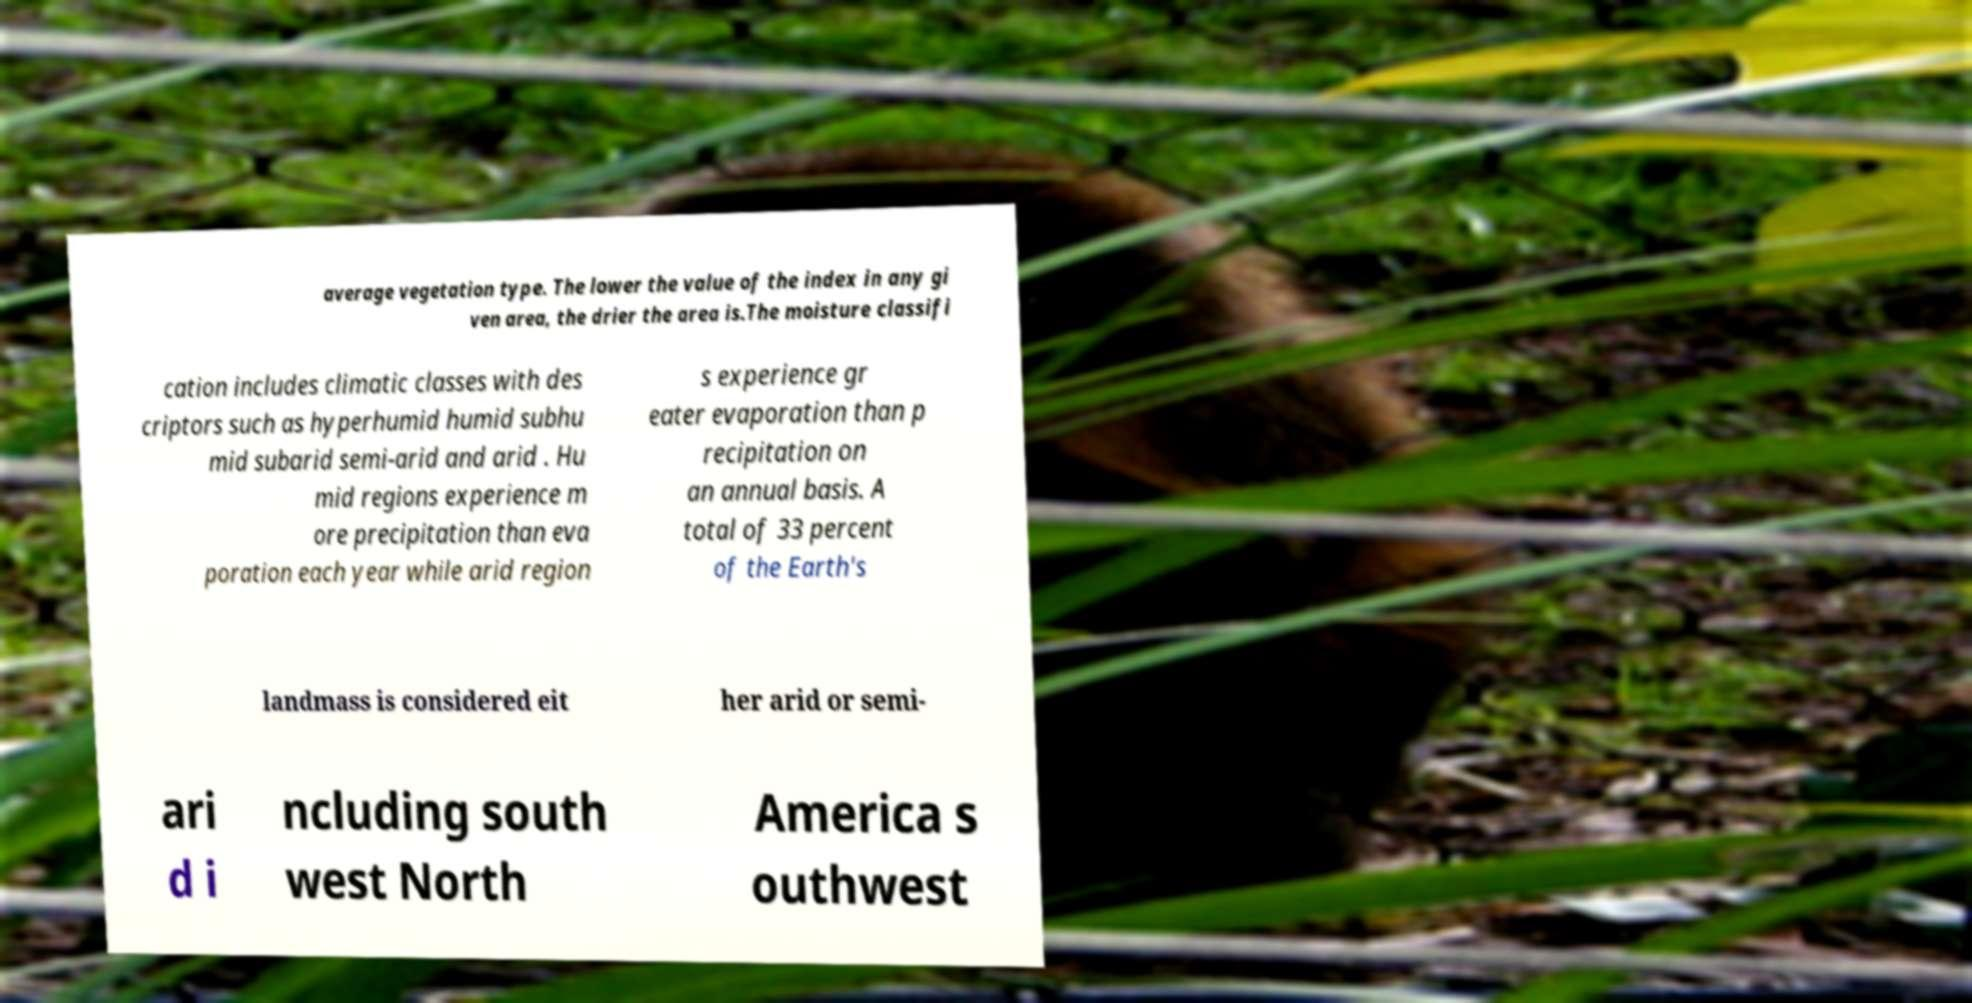There's text embedded in this image that I need extracted. Can you transcribe it verbatim? average vegetation type. The lower the value of the index in any gi ven area, the drier the area is.The moisture classifi cation includes climatic classes with des criptors such as hyperhumid humid subhu mid subarid semi-arid and arid . Hu mid regions experience m ore precipitation than eva poration each year while arid region s experience gr eater evaporation than p recipitation on an annual basis. A total of 33 percent of the Earth's landmass is considered eit her arid or semi- ari d i ncluding south west North America s outhwest 